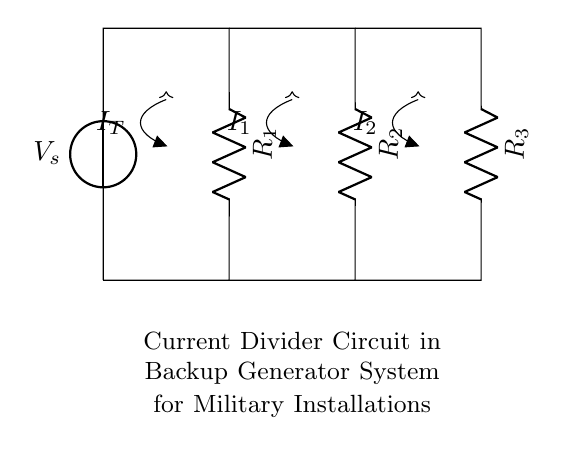What is the voltage source in the circuit? The voltage source is labeled as V_s, which represents the input voltage for the current divider circuit.
Answer: V_s What are the resistors labeled in the circuit? The resistors are labeled R_1, R_2, and R_3, indicating their positions in the current divider configuration.
Answer: R_1, R_2, R_3 How is the total current defined in this circuit? The total current is defined as I_T, which is the current entering the node where the resistors are connected.
Answer: I_T What type of circuit configuration is used here? The circuit configuration is a parallel arrangement of resistors, where the current divides among R_1, R_2, and R_3.
Answer: Parallel What can you infer about current division in this circuit? Current division means that the total current I_T splits into different paths according to the resistance values; lower resistance receives more current.
Answer: Current division How does the resistance R_2 affect its current compared to R_1? If R_2 has a lower resistance value than R_1, it will allow more current I_2 to flow through it compared to the current I_1 through R_1 due to the inverse relationship of current and resistance in a parallel circuit.
Answer: More current in R_2 What is the relationship between the total current and the individual branch currents? The relationship is given by I_T = I_1 + I_2 + I_3, signifying that the total current entering the circuit is the sum of the currents flowing through each resistor.
Answer: I_T = I_1 + I_2 + I_3 